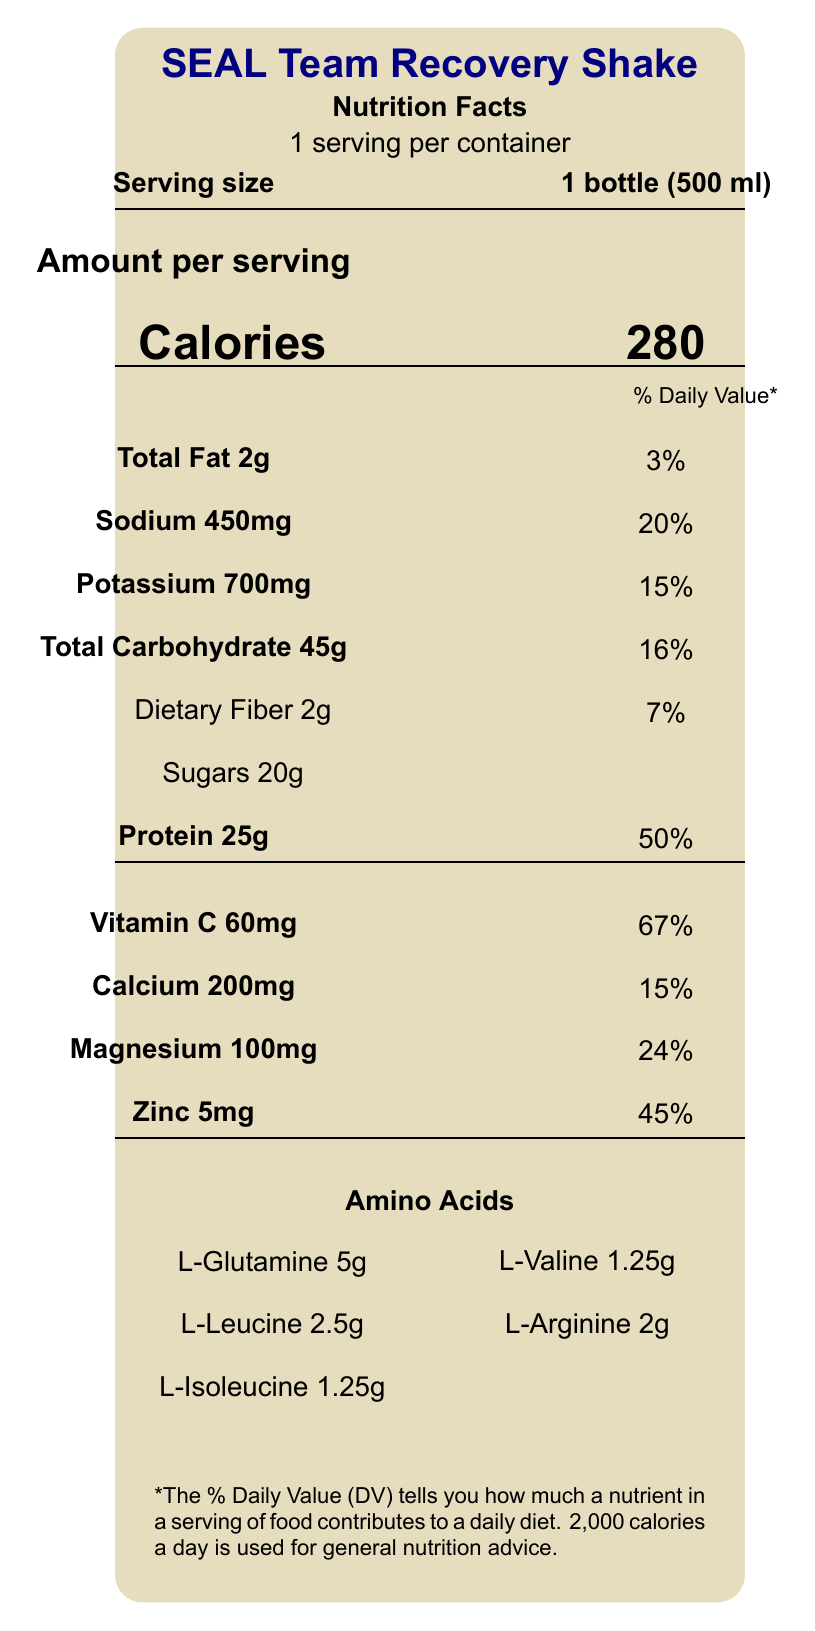what is the serving size? The serving size is clearly indicated in the document as 1 bottle (500 ml).
Answer: 1 bottle (500 ml) how many calories are in one serving of the SEAL Team Recovery Shake? The document shows that each serving contains 280 calories.
Answer: 280 what is the amount of protein per serving? The document states that there are 25 grams of protein per serving, which corresponds to 50% of the daily value.
Answer: 25g what is the daily value percentage for sodium in one serving? The document indicates that one serving has 450mg of sodium, which is 20% of the daily value.
Answer: 20% which amino acid is present in the highest amount and how much? The document shows that L-Glutamine is present in the highest amount at 5 grams per serving.
Answer: L-Glutamine, 5g how much calcium does the shake provide per serving? The document specifies that one serving contains 200mg of calcium.
Answer: 200mg what percentage of the daily value for vitamin C is in one serving? The document lists that one serving of the shake provides 60mg of vitamin C, which equals 67% of the daily value.
Answer: 67% how many grams of sugars are in one serving? A. 15g B. 20g C. 25g D. 30g The document indicates that there are 20 grams of sugars per serving.
Answer: B which of the following electrolytes is present in the highest amount? A. Sodium B. Potassium C. Magnesium Potassium is present in the highest amount at 700mg per serving, compared to 450mg of sodium and 100mg of magnesium.
Answer: B is the product description tailored for a specific group of individuals? The product is specifically formulated for Navy SEALs to support muscle recovery and rapid rehydration after intense combat operations.
Answer: Yes does the recovery shake contain zinc? The document shows that the shake includes 5mg of zinc, which is 45% of the daily value.
Answer: Yes summarize the main idea of the document. The SEAL Team Recovery Shake's nutrient profile includes calories, fats, carbohydrates, proteins, vitamins, minerals, and amino acids. The product is specifically designed for Navy SEALs to aid in post-combat recovery, focusing on muscle repair and hydration.
Answer: The document provides a detailed nutrient profile of the SEAL Team Recovery Shake, which is aimed at Navy SEALs for post-combat recovery. It highlights key nutrients, including electrolytes and amino acids, along with their amounts and daily values. The shake is designed to support muscle repair and rehydration after intense activities. what is the manufacturing facility's allergen warning? The allergen information clearly states that the product contains milk and may be processed in a facility dealing with soy and tree nuts.
Answer: Contains milk. Produced in a facility that also processes soy and tree nuts. what are the storage instructions for the SEAL Team Recovery Shake? The document instructs to keep the product refrigerated and consume it within 3 days of opening for optimal quality.
Answer: Keep refrigerated. Consume within 3 days of opening. is there information on the price of the SEAL Team Recovery Shake? The document does not contain any information regarding the price of the product.
Answer: Not enough information 